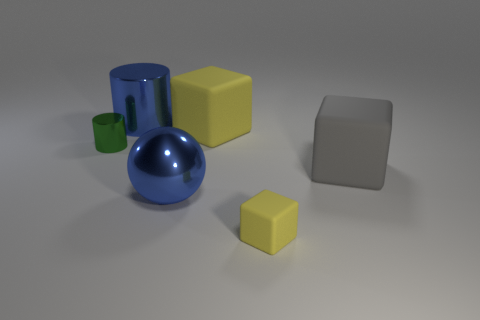What is the shape of the small object that is to the left of the shiny cylinder that is behind the large cube on the left side of the gray rubber thing?
Offer a terse response. Cylinder. What number of tiny yellow objects are behind the big blue metal object behind the big yellow rubber object?
Offer a very short reply. 0. Does the tiny green cylinder have the same material as the large blue ball?
Provide a short and direct response. Yes. There is a large metallic thing in front of the yellow matte block behind the small block; how many big cubes are in front of it?
Offer a very short reply. 0. The matte object in front of the large ball is what color?
Provide a short and direct response. Yellow. There is a large rubber object that is left of the small thing in front of the tiny green thing; what shape is it?
Your response must be concise. Cube. Does the big metallic ball have the same color as the small cube?
Ensure brevity in your answer.  No. How many cylinders are small purple matte objects or blue metallic objects?
Your response must be concise. 1. What is the thing that is both in front of the blue metallic cylinder and to the left of the blue metallic sphere made of?
Make the answer very short. Metal. What number of large gray cubes are to the left of the big metallic cylinder?
Provide a short and direct response. 0. 